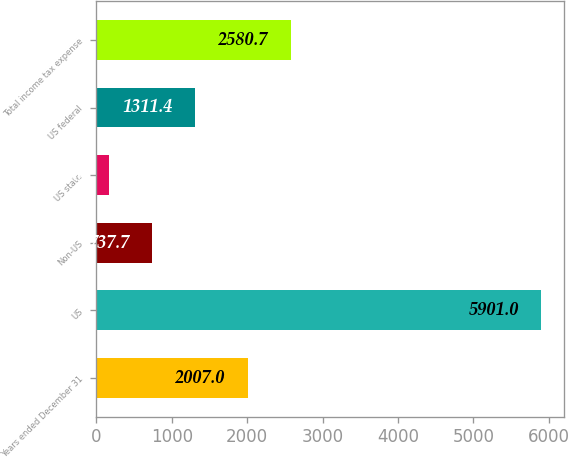<chart> <loc_0><loc_0><loc_500><loc_500><bar_chart><fcel>Years ended December 31<fcel>US<fcel>Non-US<fcel>US state<fcel>US federal<fcel>Total income tax expense<nl><fcel>2007<fcel>5901<fcel>737.7<fcel>164<fcel>1311.4<fcel>2580.7<nl></chart> 